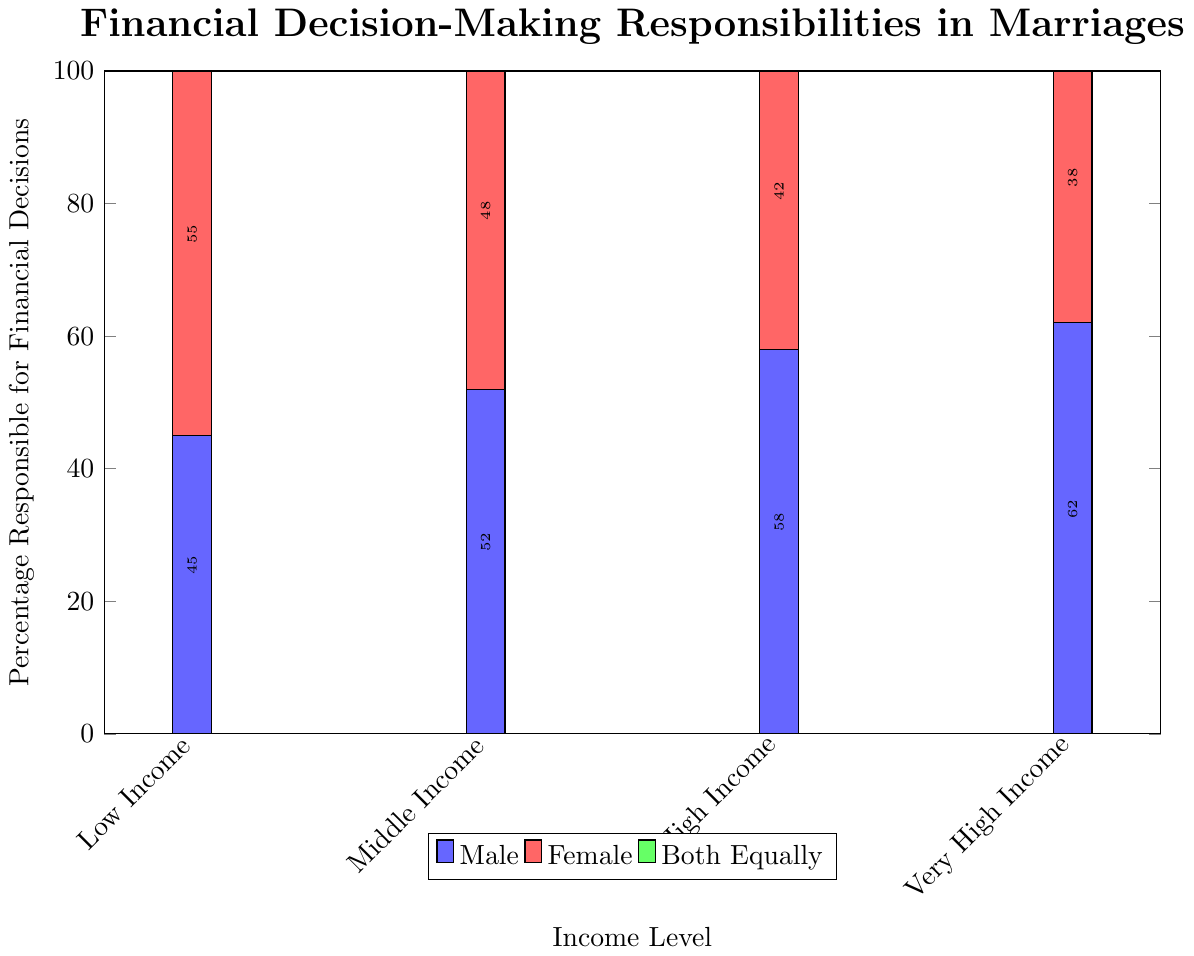What is the overall trend in who is responsible for financial decisions as income level increases? The trend shows that as income levels increase, the percentage of males responsible for financial decisions increases, whereas the percentage of females responsible generally decreases. The responsibility shared equally also increases slightly.
Answer: Males' responsibility increases; females' responsibility decreases; equal responsibility slightly increases Who has the highest percentage of responsibility for financial decisions in low-income families? To find the highest percentage in low-income families, we compare: Male (45%), Female (55%), Both Equally (30%). Females have the highest percentage.
Answer: Females What is the percentage difference between males and females responsible for financial decisions in high-income families? In high-income families, the percentage of males responsible is 58% and females is 42%. The difference is calculated as: 58% - 42% = 16%.
Answer: 16% Which group sees the largest increase in shared responsibility as income levels increase from low income to very high income? Calculate the differences in percentage of shared responsibility: Low income (30%), Very high income (45%). Increase is 45% - 30% = 15%. This is the largest increase observed among the groups.
Answer: Both Equally By how many percentage points do financial decision responsibilities by females decrease as income moves from middle income to very high income? For middle income, females have 48% responsibility, and for very high income, they have 38%. The decrease is 48% - 38% = 10%.
Answer: 10% How does the percentage of shared financial decision responsibilities change from low income to high income levels? The percentages for shared responsibilities are: Low Income (30%), Middle Income (35%), High Income (40%). The change is observed as increasing steps of 5% between each level.
Answer: It increases by 5% with each step In middle-income families, who has a greater responsibility for financial decisions, and by how much? In middle-income families, males (52%) have greater responsibility than females (48%). The difference is 52% - 48% = 4%.
Answer: Males by 4% Compare the visual heights of the bars representing males and females in very high income levels. Which bar is taller and by how much? The bar heights for very high income are: Males (62%), Females (38%). Males' bar is taller, and the height difference is 62% - 38% = 24%.
Answer: Males by 24% What is the combined percentage of financial decision responsibilities for males and females in high-income families? For high-income families, add the percentages of males (58%) and females (42%): 58% + 42% = 100%.
Answer: 100% In which income category do couples equally share financial decision responsibilities the most? Comparing the equal share percentages: Low Income (30%), Middle Income (35%), High Income (40%), Very High Income (45%). The highest percentage is in very high income (45%).
Answer: Very High Income 